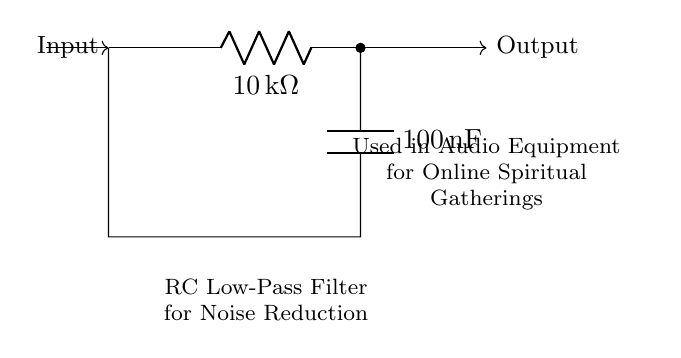What type of filter is this circuit? The circuit is an RC low-pass filter, which allows low-frequency signals to pass while attenuating high-frequency signals. This is identifiable from the arrangement of the resistor and capacitor in the circuit.
Answer: RC low-pass filter What is the resistance value in the circuit? The resistance value is indicated as 10 kΩ, clearly labeled next to the resistor symbol in the circuit diagram.
Answer: 10 kΩ What is the capacitance value in this circuit? The capacitance value is shown as 100 nF, which associates with the capacitor in the circuit. The value is directly indicated next to the capacitor symbol.
Answer: 100 nF What effect does this circuit have on audio signals? This circuit reduces noise in audio signals by filtering out high-frequency components, thereby improving the overall quality of audio for clear communication during online gatherings.
Answer: Noise reduction Why is an RC filter useful for online spiritual gatherings? An RC filter helps in minimizing disturbances and ensuring clear audio transmission during virtual gatherings, which is crucial for maintaining focus and participation. It helps create a more serene environment by reducing unwanted noise.
Answer: Ensures clear audio What happens to high-frequency signals in this circuit? High-frequency signals are attenuated, meaning their amplitude is reduced as they are not passed through the filter effectively, allowing only low-frequency components to transmit.
Answer: Attenuated What is the relationship between the resistor and capacitor in this circuit? The resistor and capacitor form an energy storage and release system, where the capacitor charges and discharges through the resistor, determining the cutoff frequency of the filter. Their combined effect is what defines the filter's characteristics.
Answer: Energy storage system 